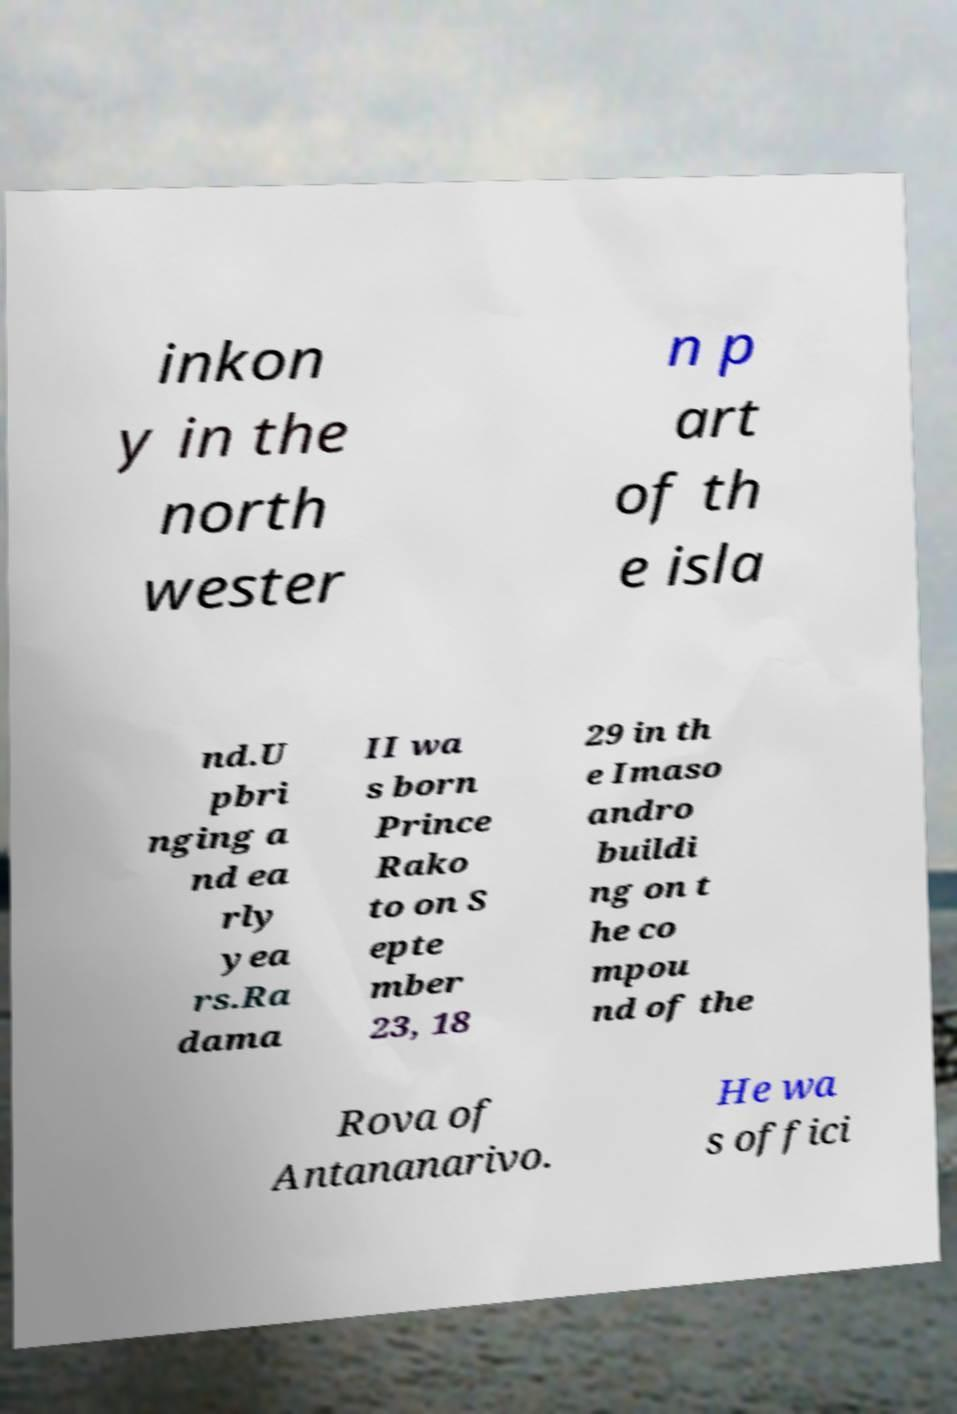What messages or text are displayed in this image? I need them in a readable, typed format. inkon y in the north wester n p art of th e isla nd.U pbri nging a nd ea rly yea rs.Ra dama II wa s born Prince Rako to on S epte mber 23, 18 29 in th e Imaso andro buildi ng on t he co mpou nd of the Rova of Antananarivo. He wa s offici 